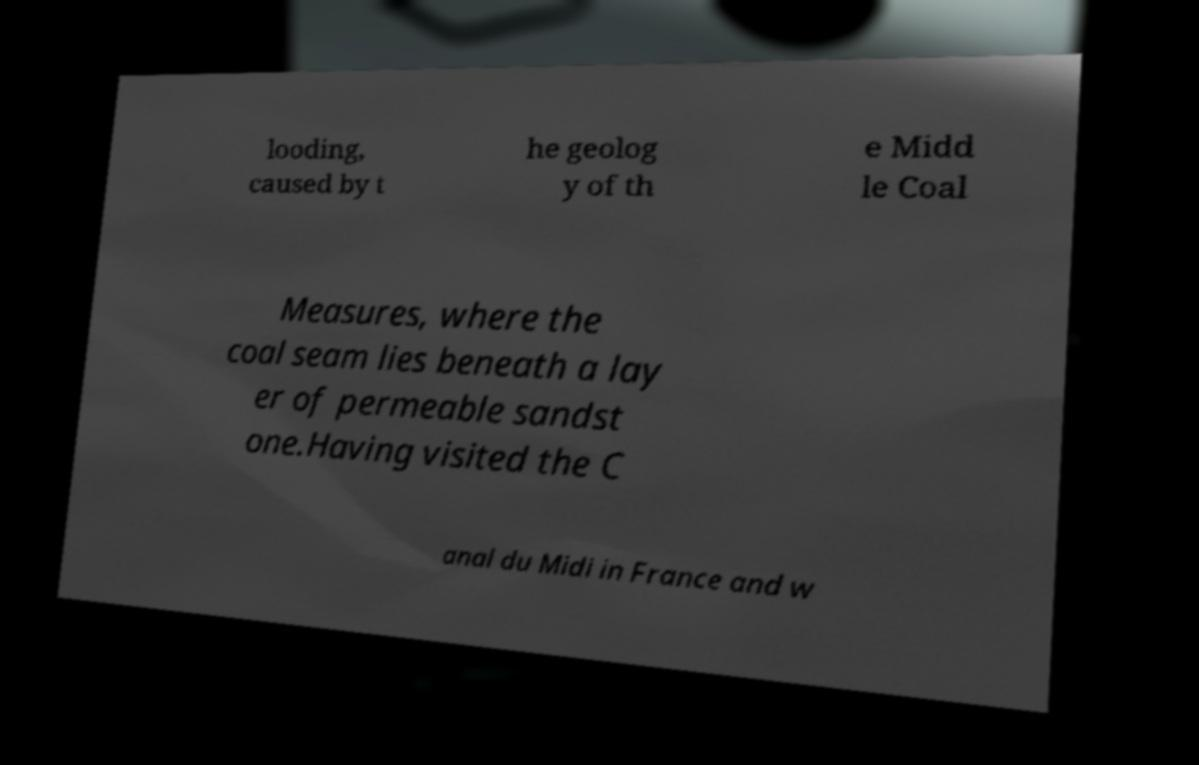Please identify and transcribe the text found in this image. looding, caused by t he geolog y of th e Midd le Coal Measures, where the coal seam lies beneath a lay er of permeable sandst one.Having visited the C anal du Midi in France and w 